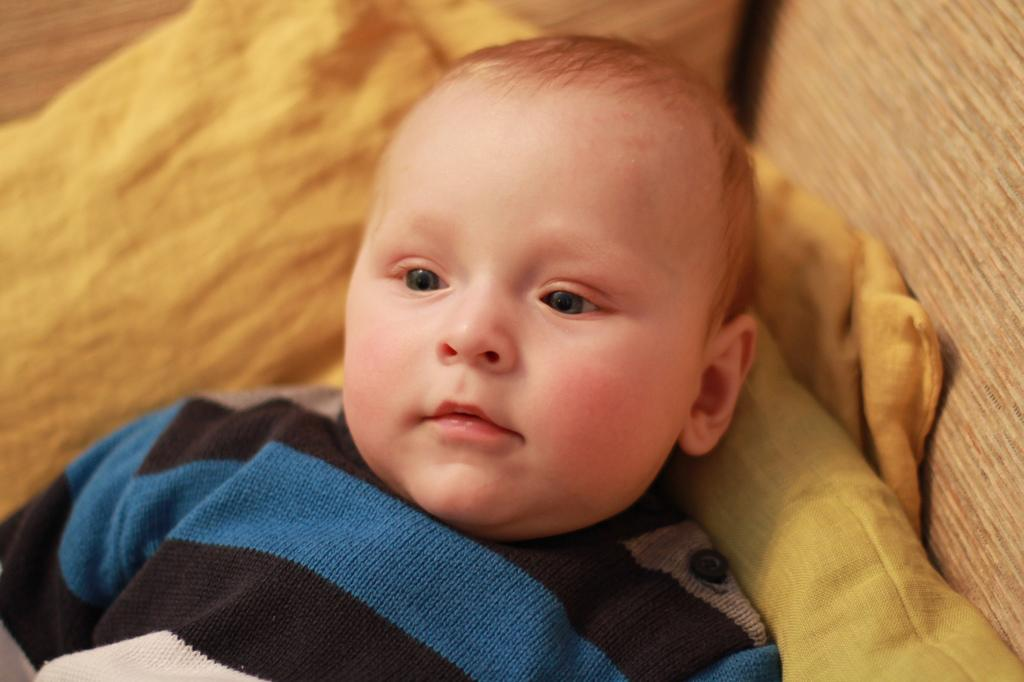What is the main subject of the image? The main subject of the image is a kid. What is the kid positioned on in the image? The kid is on a cloth in the image. What is the number of airplanes visible in the image? There are no airplanes present in the image. What role does the governor play in the image? There is no mention of a governor in the image, so it is not possible to determine their role. 